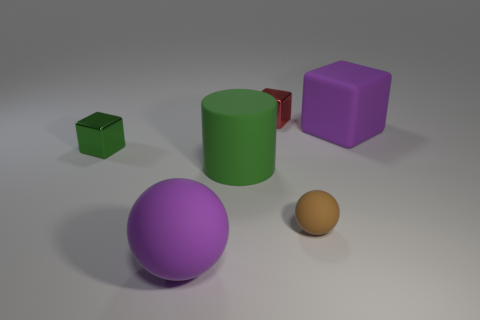Are there any yellow cubes?
Offer a very short reply. No. Is there a red metallic object that is to the left of the purple matte object in front of the small shiny block to the left of the cylinder?
Your answer should be very brief. No. Are there any other things that have the same size as the brown ball?
Offer a terse response. Yes. Is the shape of the green metallic thing the same as the large purple object to the right of the big cylinder?
Offer a very short reply. Yes. What is the color of the cube in front of the matte object behind the small cube that is left of the big purple rubber sphere?
Provide a short and direct response. Green. How many objects are small balls that are right of the purple matte sphere or purple matte objects that are behind the tiny brown rubber ball?
Ensure brevity in your answer.  2. What number of other objects are there of the same color as the cylinder?
Offer a terse response. 1. There is a thing that is to the right of the tiny brown object; is it the same shape as the brown rubber object?
Offer a terse response. No. Are there fewer purple rubber balls to the right of the tiny red shiny object than tiny yellow balls?
Keep it short and to the point. No. Are there any blocks made of the same material as the purple ball?
Provide a short and direct response. Yes. 